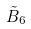<formula> <loc_0><loc_0><loc_500><loc_500>\tilde { B } _ { 6 }</formula> 